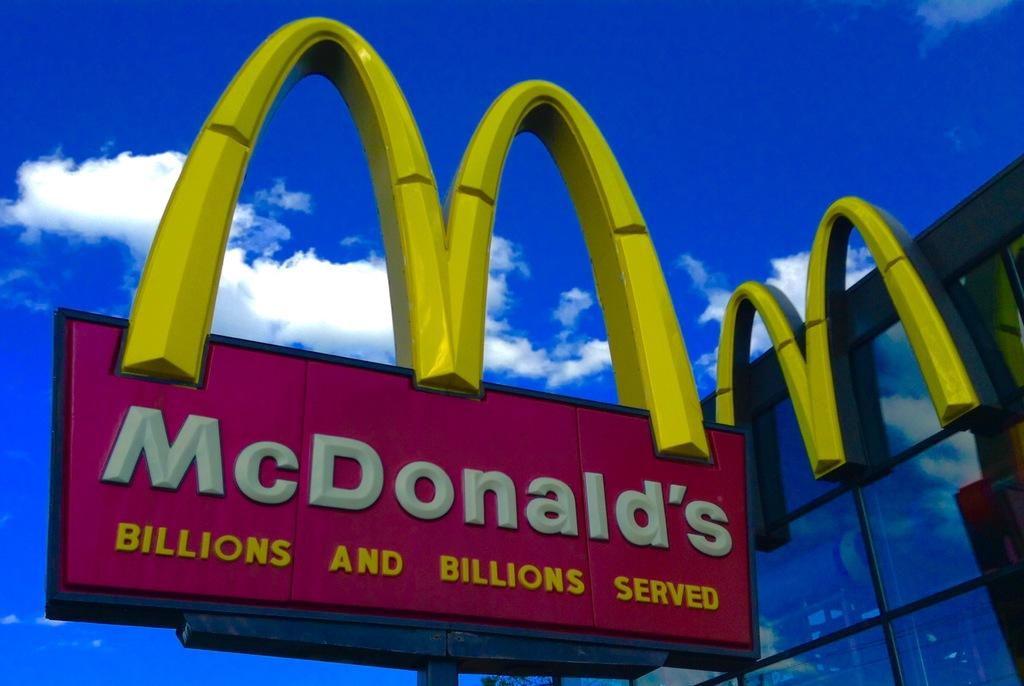<image>
Provide a brief description of the given image. The golden arches of McDonalds stand out against the blue sky. 